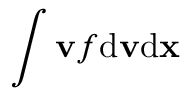Convert formula to latex. <formula><loc_0><loc_0><loc_500><loc_500>\int { \mathbf v } f d { \mathbf v } d { \mathbf x }</formula> 